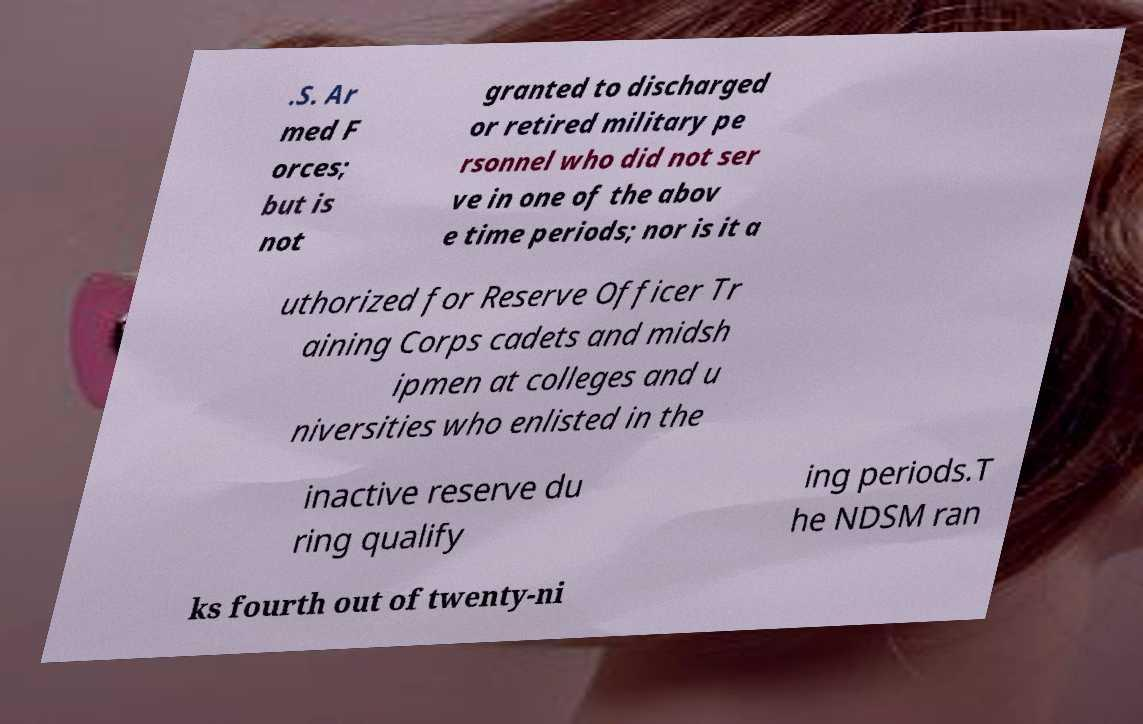For documentation purposes, I need the text within this image transcribed. Could you provide that? .S. Ar med F orces; but is not granted to discharged or retired military pe rsonnel who did not ser ve in one of the abov e time periods; nor is it a uthorized for Reserve Officer Tr aining Corps cadets and midsh ipmen at colleges and u niversities who enlisted in the inactive reserve du ring qualify ing periods.T he NDSM ran ks fourth out of twenty-ni 